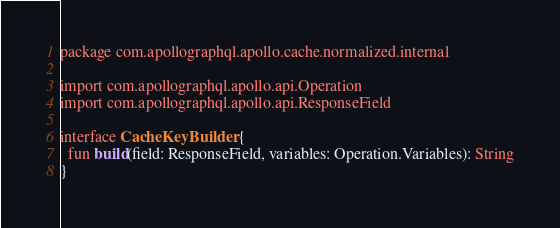<code> <loc_0><loc_0><loc_500><loc_500><_Kotlin_>package com.apollographql.apollo.cache.normalized.internal

import com.apollographql.apollo.api.Operation
import com.apollographql.apollo.api.ResponseField

interface CacheKeyBuilder {
  fun build(field: ResponseField, variables: Operation.Variables): String
}
</code> 